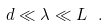<formula> <loc_0><loc_0><loc_500><loc_500>d \ll \lambda \ll L \ .</formula> 